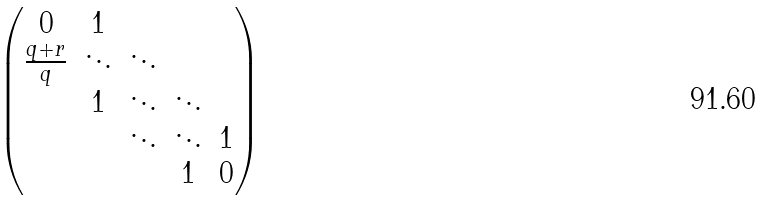Convert formula to latex. <formula><loc_0><loc_0><loc_500><loc_500>\begin{pmatrix} 0 & 1 & & & \\ \frac { q + r } { q } & \ddots & \ddots & & \\ & 1 & \ddots & \ddots & \\ & & \ddots & \ddots & 1 \\ & & & 1 & 0 \end{pmatrix}</formula> 